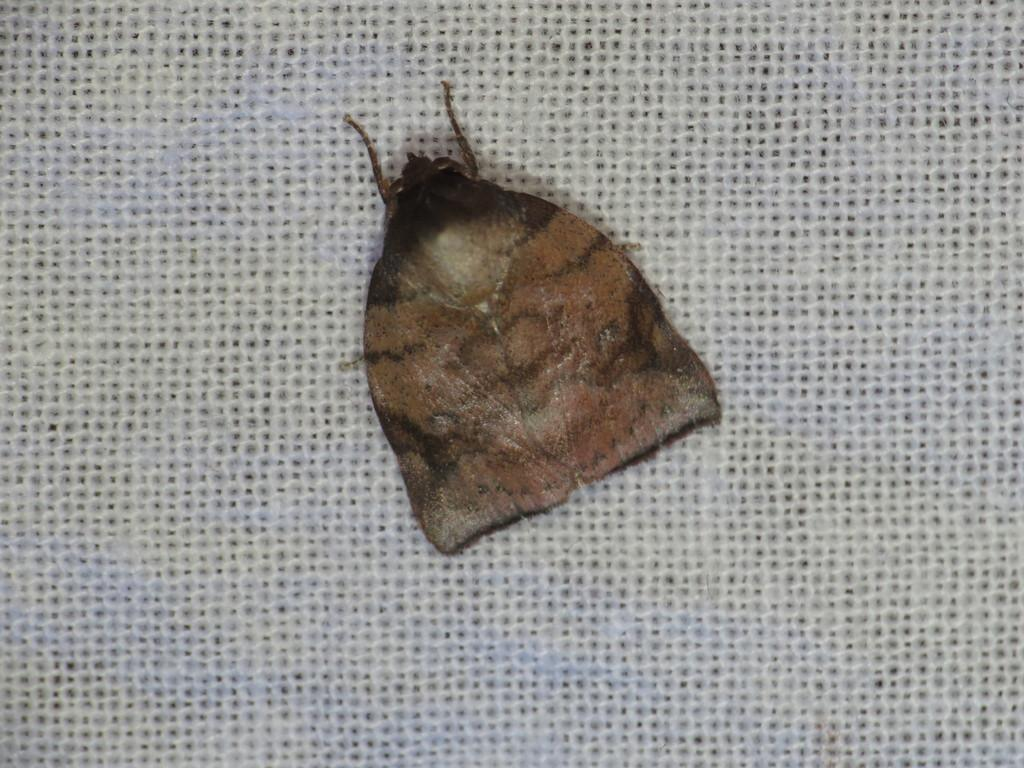What type of creature can be seen in the image? There is an insect in the image. What is the insect resting on or near in the image? The insect is on a white color object. What type of skirt is the insect wearing in the image? There is no skirt present in the image, and insects do not wear clothing. 